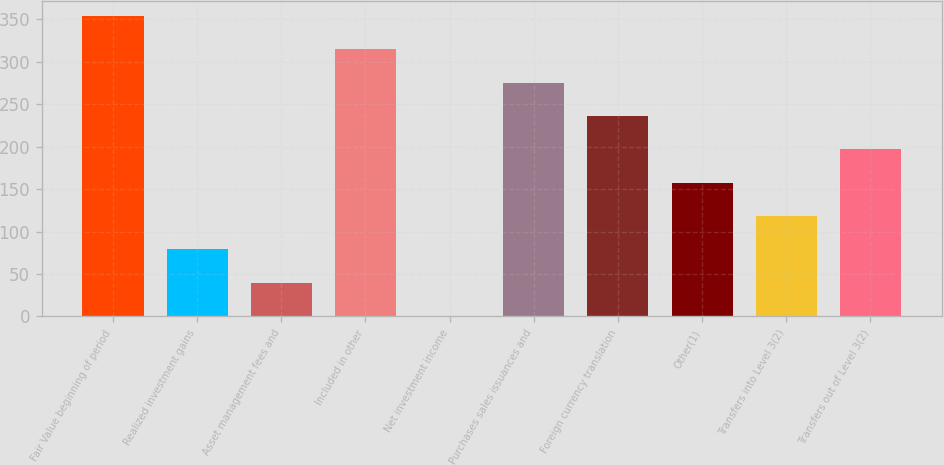Convert chart. <chart><loc_0><loc_0><loc_500><loc_500><bar_chart><fcel>Fair Value beginning of period<fcel>Realized investment gains<fcel>Asset management fees and<fcel>Included in other<fcel>Net investment income<fcel>Purchases sales issuances and<fcel>Foreign currency translation<fcel>Other(1)<fcel>Transfers into Level 3(2)<fcel>Transfers out of Level 3(2)<nl><fcel>353.73<fcel>79.05<fcel>39.81<fcel>314.49<fcel>0.57<fcel>275.25<fcel>236.01<fcel>157.53<fcel>118.29<fcel>196.77<nl></chart> 